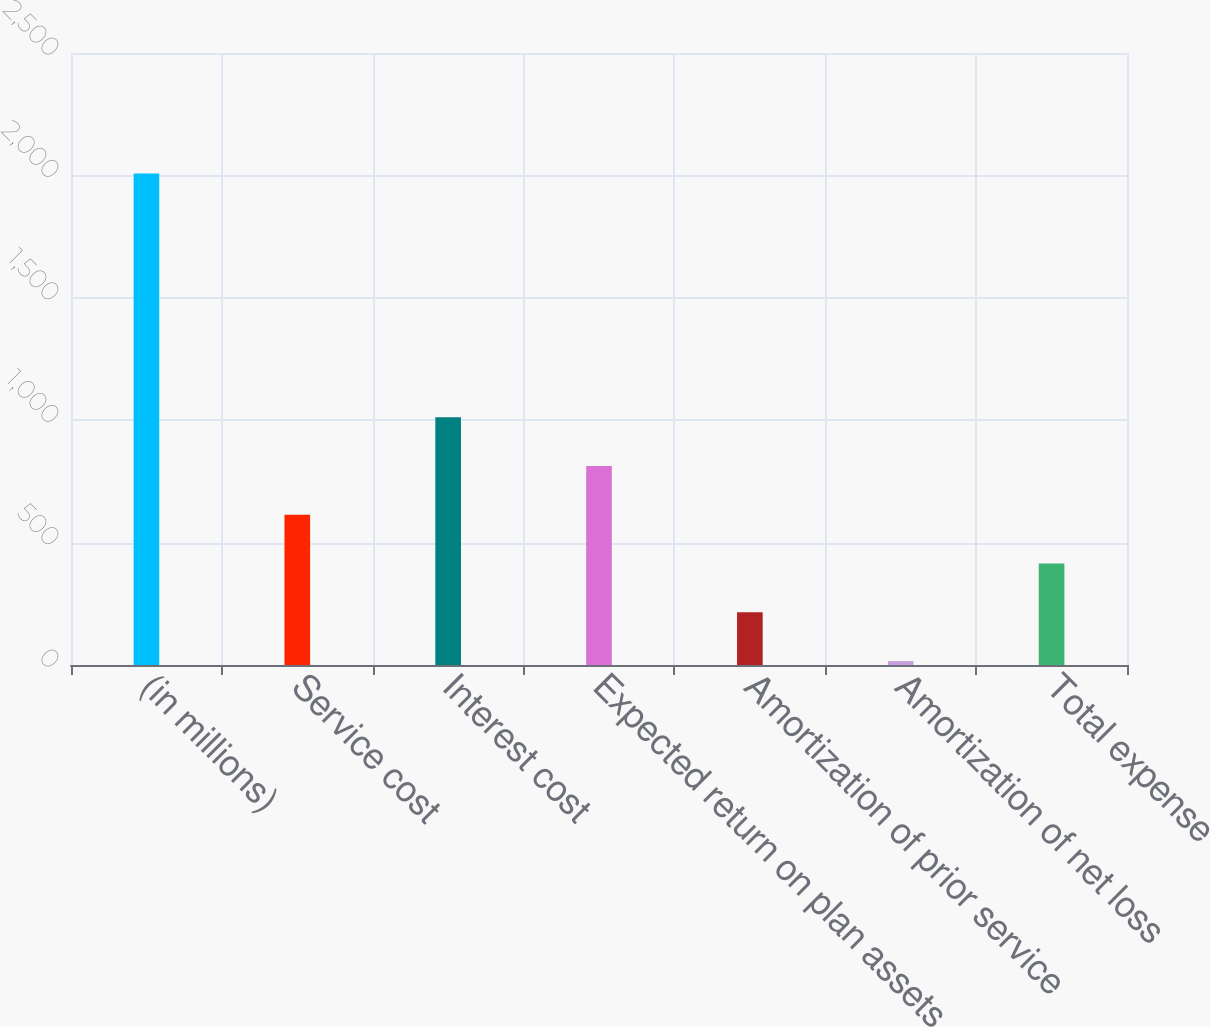Convert chart to OTSL. <chart><loc_0><loc_0><loc_500><loc_500><bar_chart><fcel>(in millions)<fcel>Service cost<fcel>Interest cost<fcel>Expected return on plan assets<fcel>Amortization of prior service<fcel>Amortization of net loss<fcel>Total expense<nl><fcel>2008<fcel>613.6<fcel>1012<fcel>812.8<fcel>215.2<fcel>16<fcel>414.4<nl></chart> 